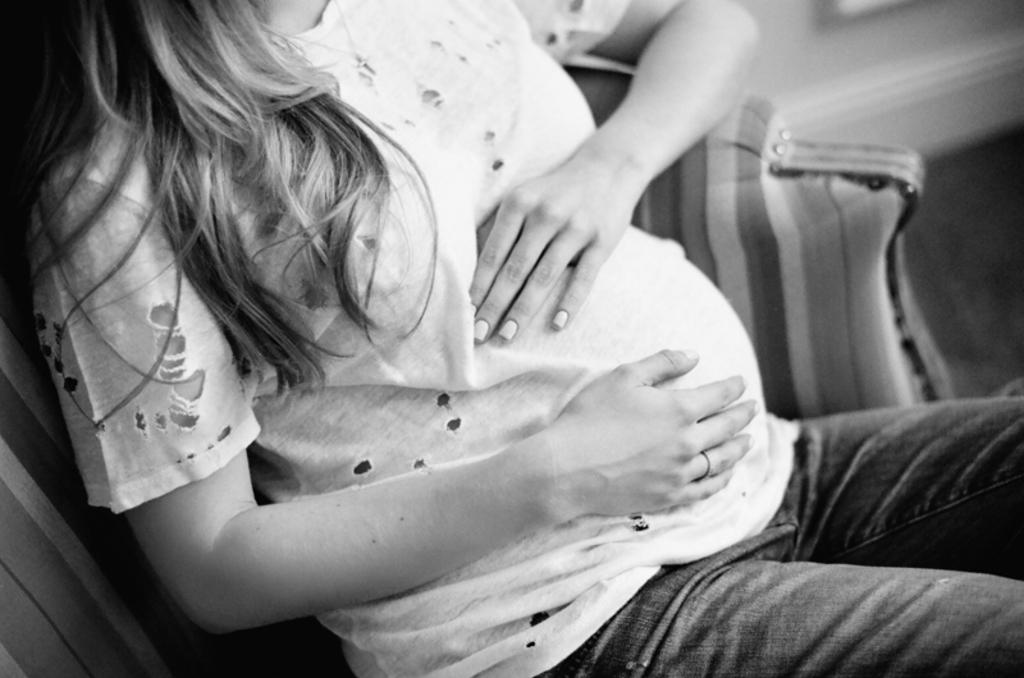Who or what is the main subject in the image? There is a person in the image. What is the person doing in the image? The person is sitting on a couch. Can you describe the background of the image? The background of the image is blurred. How many roses are on the person's lap in the image? There are no roses present in the image. What act is the person performing in the image? The person is simply sitting on a couch, and no specific act is being performed. 